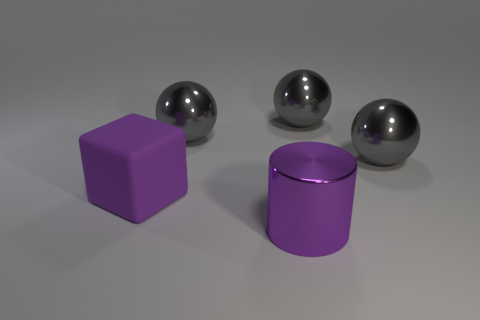Do the purple rubber object and the big purple metal thing have the same shape?
Your answer should be very brief. No. What number of things are purple matte cubes that are behind the purple cylinder or large gray shiny objects right of the big cylinder?
Offer a very short reply. 3. How many things are big things or large rubber things?
Ensure brevity in your answer.  5. What number of large metallic objects are behind the object that is in front of the purple block?
Provide a succinct answer. 3. What number of other objects are there of the same size as the cylinder?
Provide a succinct answer. 4. What is the size of the cube that is the same color as the metal cylinder?
Give a very brief answer. Large. Do the big purple object behind the big purple cylinder and the large purple shiny thing have the same shape?
Provide a succinct answer. No. What is the gray object to the left of the big purple cylinder made of?
Provide a short and direct response. Metal. There is a big shiny thing that is the same color as the large matte block; what is its shape?
Offer a terse response. Cylinder. Is there another large cylinder that has the same material as the purple cylinder?
Give a very brief answer. No. 